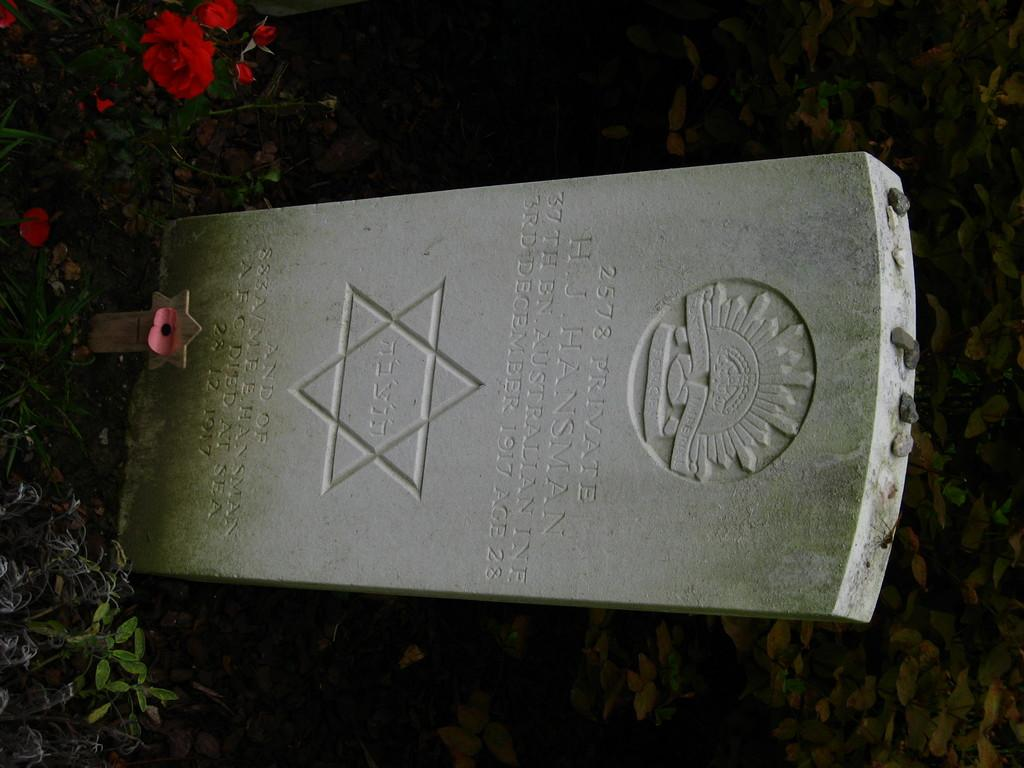What is the main subject of the picture? The main subject of the picture is a gravestone. Are there any flowers present in the image? Yes, there are red roses in the top left corner of the picture. What type of vegetation can be seen at the bottom of the picture? There are dry leaves and grass at the bottom of the picture. What type of oatmeal is being served on the gravestone in the image? There is no oatmeal present in the image; it features a gravestone and red roses. How many drops of water can be seen falling from the sky in the image? There is no mention of rain or water drops in the image; it only shows a gravestone, red roses, dry leaves, and grass. 